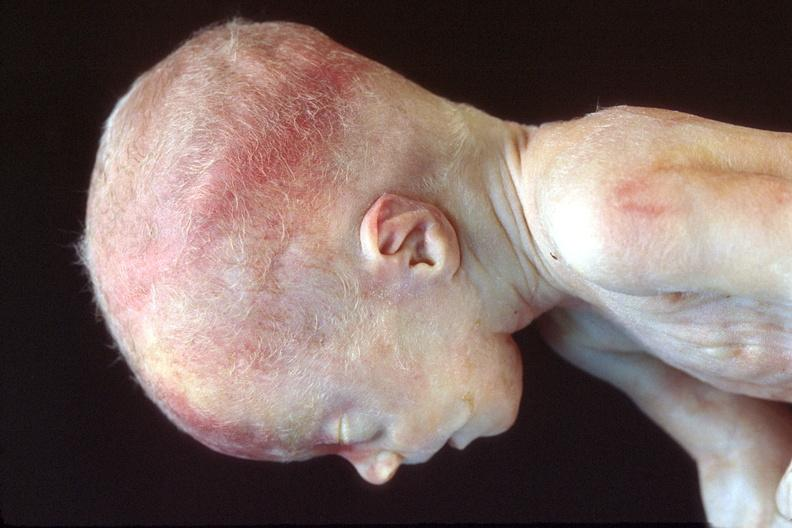what does this image show?
Answer the question using a single word or phrase. Hyaline membrane disease 